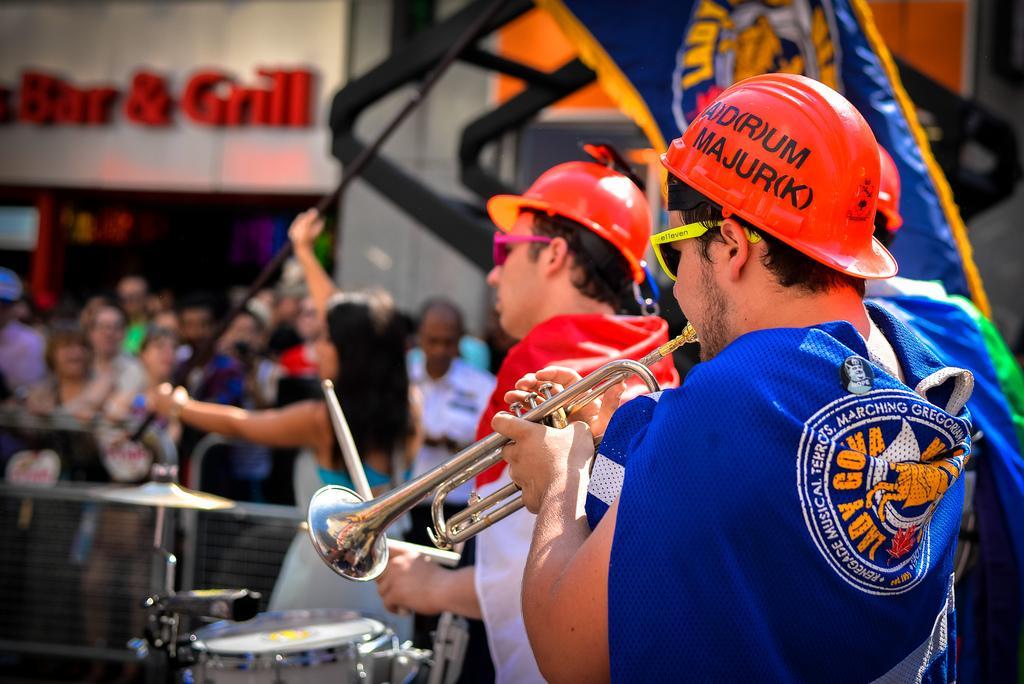Could you give a brief overview of what you see in this image? In this image we can see few people playing musical instruments. A person is holding a flag in the image. There are many people in the image. There is a store in the image. We can see some text on the wall at the left side of the image. 